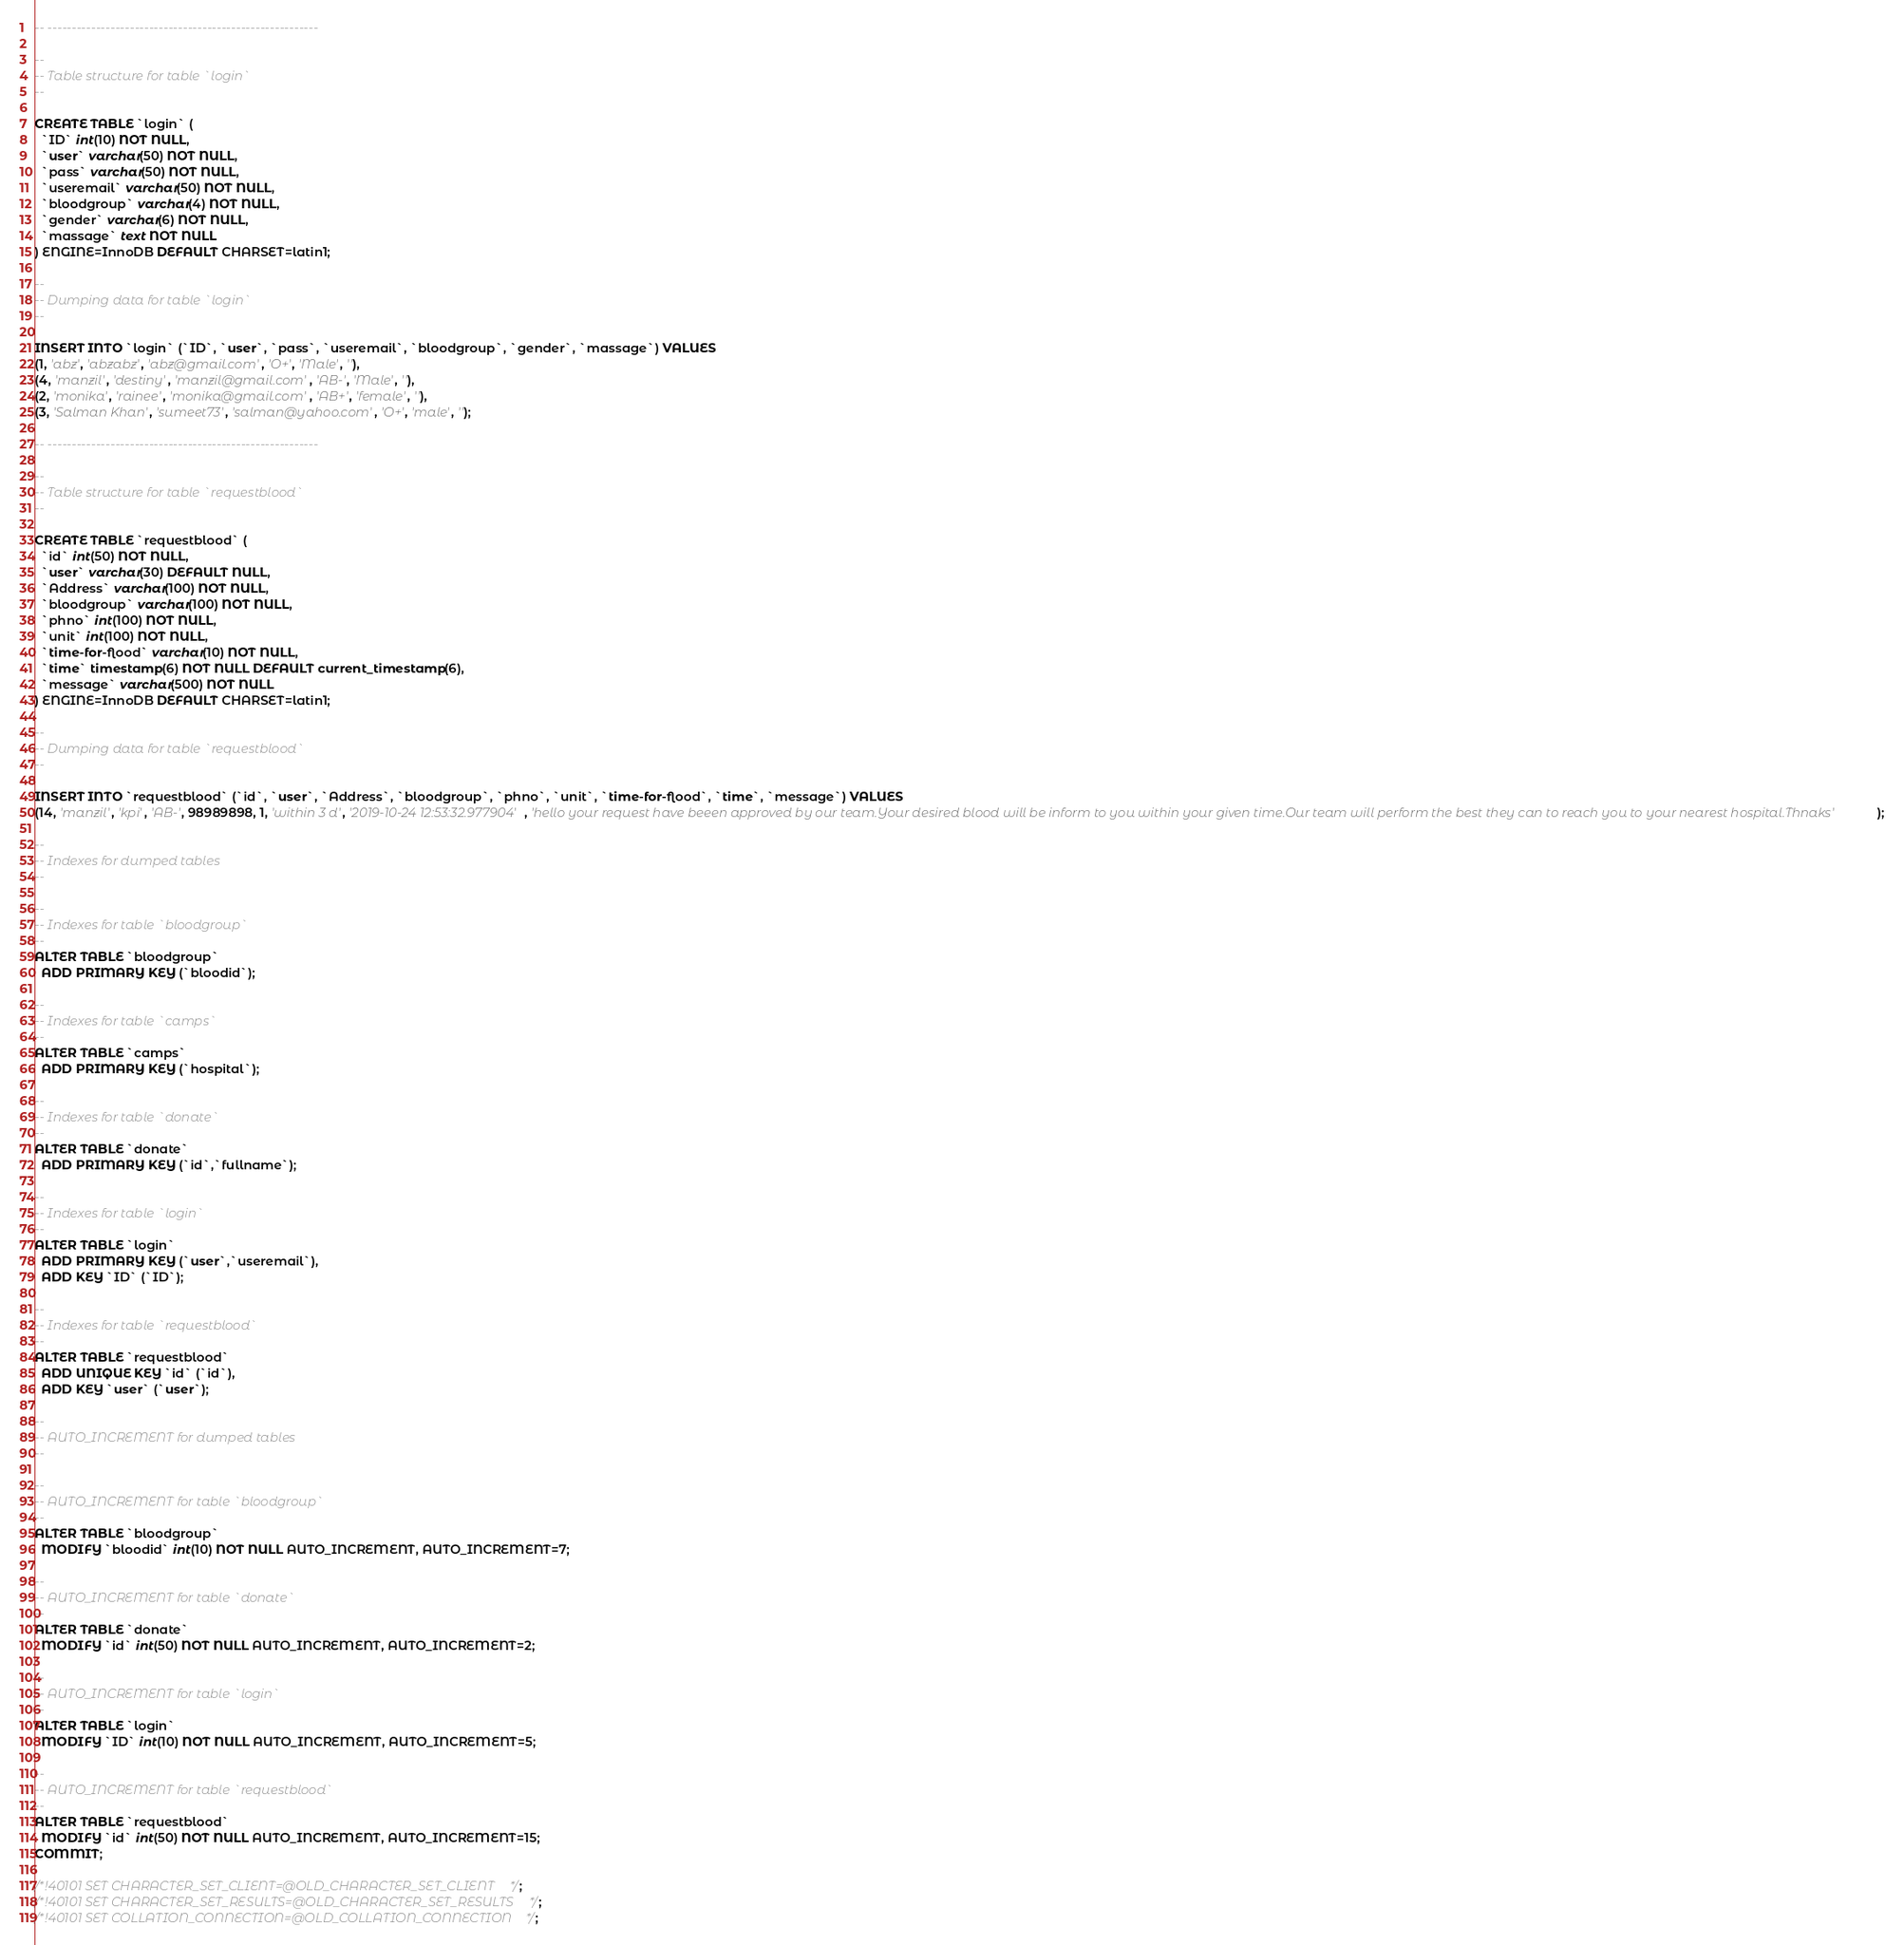Convert code to text. <code><loc_0><loc_0><loc_500><loc_500><_SQL_>
-- --------------------------------------------------------

--
-- Table structure for table `login`
--

CREATE TABLE `login` (
  `ID` int(10) NOT NULL,
  `user` varchar(50) NOT NULL,
  `pass` varchar(50) NOT NULL,
  `useremail` varchar(50) NOT NULL,
  `bloodgroup` varchar(4) NOT NULL,
  `gender` varchar(6) NOT NULL,
  `massage` text NOT NULL
) ENGINE=InnoDB DEFAULT CHARSET=latin1;

--
-- Dumping data for table `login`
--

INSERT INTO `login` (`ID`, `user`, `pass`, `useremail`, `bloodgroup`, `gender`, `massage`) VALUES
(1, 'abz', 'abzabz', 'abz@gmail.com', 'O+', 'Male', ''),
(4, 'manzil', 'destiny', 'manzil@gmail.com', 'AB-', 'Male', ''),
(2, 'monika', 'rainee', 'monika@gmail.com', 'AB+', 'female', ''),
(3, 'Salman Khan', 'sumeet73', 'salman@yahoo.com', 'O+', 'male', '');

-- --------------------------------------------------------

--
-- Table structure for table `requestblood`
--

CREATE TABLE `requestblood` (
  `id` int(50) NOT NULL,
  `user` varchar(30) DEFAULT NULL,
  `Address` varchar(100) NOT NULL,
  `bloodgroup` varchar(100) NOT NULL,
  `phno` int(100) NOT NULL,
  `unit` int(100) NOT NULL,
  `time-for-flood` varchar(10) NOT NULL,
  `time` timestamp(6) NOT NULL DEFAULT current_timestamp(6),
  `message` varchar(500) NOT NULL
) ENGINE=InnoDB DEFAULT CHARSET=latin1;

--
-- Dumping data for table `requestblood`
--

INSERT INTO `requestblood` (`id`, `user`, `Address`, `bloodgroup`, `phno`, `unit`, `time-for-flood`, `time`, `message`) VALUES
(14, 'manzil', 'kpi', 'AB-', 98989898, 1, 'within 3 d', '2019-10-24 12:53:32.977904', 'hello your request have beeen approved by our team.Your desired blood will be inform to you within your given time.Our team will perform the best they can to reach you to your nearest hospital.Thnaks');

--
-- Indexes for dumped tables
--

--
-- Indexes for table `bloodgroup`
--
ALTER TABLE `bloodgroup`
  ADD PRIMARY KEY (`bloodid`);

--
-- Indexes for table `camps`
--
ALTER TABLE `camps`
  ADD PRIMARY KEY (`hospital`);

--
-- Indexes for table `donate`
--
ALTER TABLE `donate`
  ADD PRIMARY KEY (`id`,`fullname`);

--
-- Indexes for table `login`
--
ALTER TABLE `login`
  ADD PRIMARY KEY (`user`,`useremail`),
  ADD KEY `ID` (`ID`);

--
-- Indexes for table `requestblood`
--
ALTER TABLE `requestblood`
  ADD UNIQUE KEY `id` (`id`),
  ADD KEY `user` (`user`);

--
-- AUTO_INCREMENT for dumped tables
--

--
-- AUTO_INCREMENT for table `bloodgroup`
--
ALTER TABLE `bloodgroup`
  MODIFY `bloodid` int(10) NOT NULL AUTO_INCREMENT, AUTO_INCREMENT=7;

--
-- AUTO_INCREMENT for table `donate`
--
ALTER TABLE `donate`
  MODIFY `id` int(50) NOT NULL AUTO_INCREMENT, AUTO_INCREMENT=2;

--
-- AUTO_INCREMENT for table `login`
--
ALTER TABLE `login`
  MODIFY `ID` int(10) NOT NULL AUTO_INCREMENT, AUTO_INCREMENT=5;

--
-- AUTO_INCREMENT for table `requestblood`
--
ALTER TABLE `requestblood`
  MODIFY `id` int(50) NOT NULL AUTO_INCREMENT, AUTO_INCREMENT=15;
COMMIT;

/*!40101 SET CHARACTER_SET_CLIENT=@OLD_CHARACTER_SET_CLIENT */;
/*!40101 SET CHARACTER_SET_RESULTS=@OLD_CHARACTER_SET_RESULTS */;
/*!40101 SET COLLATION_CONNECTION=@OLD_COLLATION_CONNECTION */;
</code> 